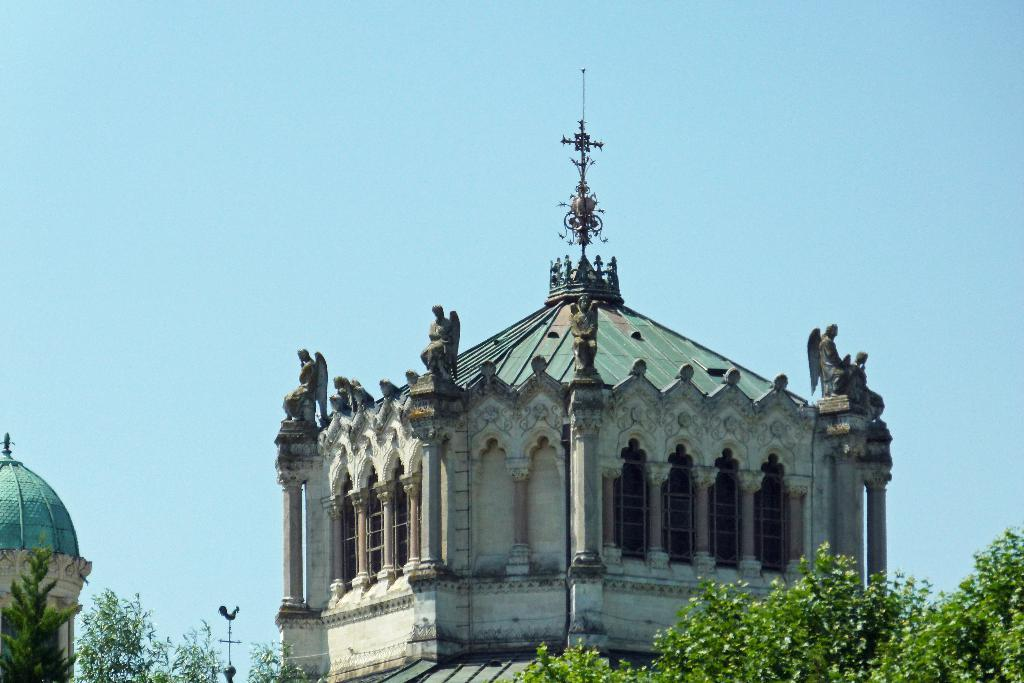What type of structure is visible in the image? There is a building in the image. What feature can be seen on the building? The building has windows. What other objects are present in the image besides the building? There are statues and trees in the image. What type of comb is being used by the statue in the image? There are no combs present in the image, and the statues do not have any visible hair or fur that would require a comb. 